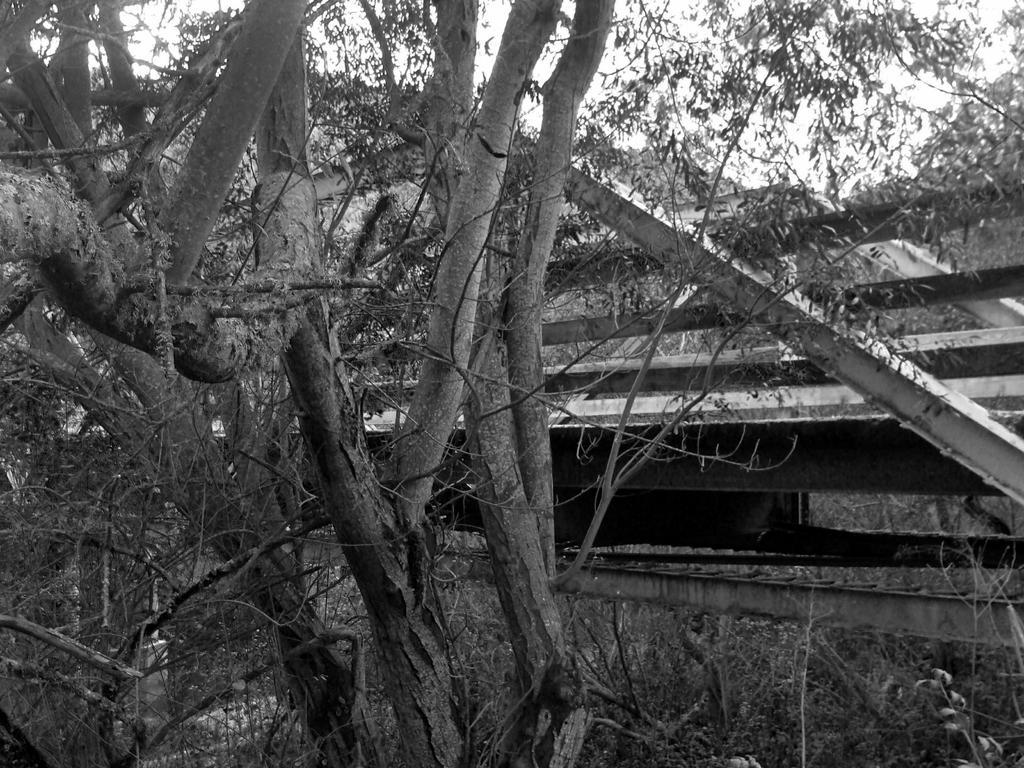Could you give a brief overview of what you see in this image? Black and white picture. Here we can see dried branches, leaves and rods. 